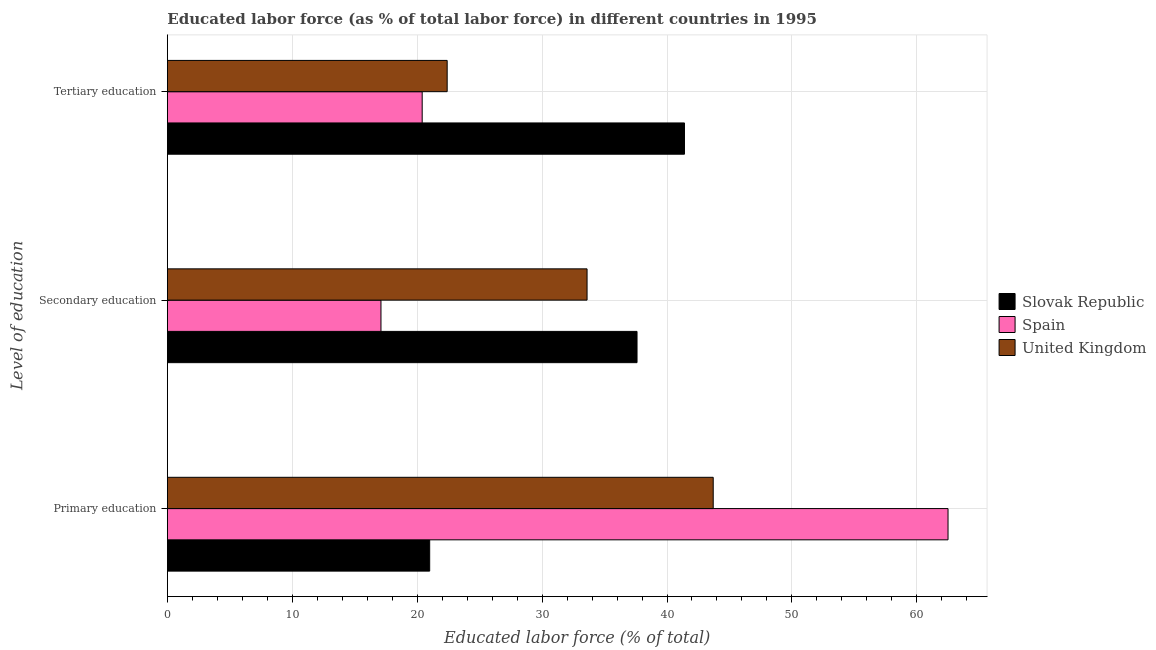How many different coloured bars are there?
Make the answer very short. 3. Are the number of bars per tick equal to the number of legend labels?
Give a very brief answer. Yes. How many bars are there on the 2nd tick from the top?
Offer a very short reply. 3. What is the label of the 2nd group of bars from the top?
Your answer should be very brief. Secondary education. What is the percentage of labor force who received secondary education in Spain?
Your answer should be very brief. 17.1. Across all countries, what is the maximum percentage of labor force who received tertiary education?
Provide a short and direct response. 41.4. In which country was the percentage of labor force who received primary education maximum?
Your response must be concise. Spain. In which country was the percentage of labor force who received secondary education minimum?
Your response must be concise. Spain. What is the total percentage of labor force who received primary education in the graph?
Provide a short and direct response. 127.2. What is the difference between the percentage of labor force who received tertiary education in United Kingdom and that in Spain?
Offer a terse response. 2. What is the difference between the percentage of labor force who received tertiary education in Spain and the percentage of labor force who received primary education in United Kingdom?
Ensure brevity in your answer.  -23.3. What is the average percentage of labor force who received secondary education per country?
Your answer should be very brief. 29.43. What is the difference between the percentage of labor force who received primary education and percentage of labor force who received secondary education in Slovak Republic?
Ensure brevity in your answer.  -16.6. What is the ratio of the percentage of labor force who received secondary education in Spain to that in United Kingdom?
Your answer should be compact. 0.51. Is the difference between the percentage of labor force who received primary education in United Kingdom and Spain greater than the difference between the percentage of labor force who received secondary education in United Kingdom and Spain?
Provide a short and direct response. No. What is the difference between the highest and the lowest percentage of labor force who received secondary education?
Give a very brief answer. 20.5. In how many countries, is the percentage of labor force who received primary education greater than the average percentage of labor force who received primary education taken over all countries?
Make the answer very short. 2. What does the 1st bar from the top in Secondary education represents?
Your response must be concise. United Kingdom. What does the 1st bar from the bottom in Primary education represents?
Offer a terse response. Slovak Republic. How many bars are there?
Provide a succinct answer. 9. Are all the bars in the graph horizontal?
Keep it short and to the point. Yes. How many countries are there in the graph?
Your answer should be very brief. 3. Are the values on the major ticks of X-axis written in scientific E-notation?
Keep it short and to the point. No. Where does the legend appear in the graph?
Your answer should be compact. Center right. What is the title of the graph?
Offer a terse response. Educated labor force (as % of total labor force) in different countries in 1995. What is the label or title of the X-axis?
Offer a very short reply. Educated labor force (% of total). What is the label or title of the Y-axis?
Your answer should be very brief. Level of education. What is the Educated labor force (% of total) of Slovak Republic in Primary education?
Your response must be concise. 21. What is the Educated labor force (% of total) in Spain in Primary education?
Give a very brief answer. 62.5. What is the Educated labor force (% of total) in United Kingdom in Primary education?
Keep it short and to the point. 43.7. What is the Educated labor force (% of total) in Slovak Republic in Secondary education?
Provide a succinct answer. 37.6. What is the Educated labor force (% of total) in Spain in Secondary education?
Provide a succinct answer. 17.1. What is the Educated labor force (% of total) in United Kingdom in Secondary education?
Make the answer very short. 33.6. What is the Educated labor force (% of total) of Slovak Republic in Tertiary education?
Your answer should be compact. 41.4. What is the Educated labor force (% of total) in Spain in Tertiary education?
Give a very brief answer. 20.4. What is the Educated labor force (% of total) of United Kingdom in Tertiary education?
Provide a succinct answer. 22.4. Across all Level of education, what is the maximum Educated labor force (% of total) in Slovak Republic?
Give a very brief answer. 41.4. Across all Level of education, what is the maximum Educated labor force (% of total) in Spain?
Make the answer very short. 62.5. Across all Level of education, what is the maximum Educated labor force (% of total) of United Kingdom?
Your response must be concise. 43.7. Across all Level of education, what is the minimum Educated labor force (% of total) of Spain?
Provide a succinct answer. 17.1. Across all Level of education, what is the minimum Educated labor force (% of total) in United Kingdom?
Offer a terse response. 22.4. What is the total Educated labor force (% of total) in Slovak Republic in the graph?
Offer a very short reply. 100. What is the total Educated labor force (% of total) in Spain in the graph?
Your answer should be very brief. 100. What is the total Educated labor force (% of total) in United Kingdom in the graph?
Provide a short and direct response. 99.7. What is the difference between the Educated labor force (% of total) in Slovak Republic in Primary education and that in Secondary education?
Provide a short and direct response. -16.6. What is the difference between the Educated labor force (% of total) of Spain in Primary education and that in Secondary education?
Your answer should be compact. 45.4. What is the difference between the Educated labor force (% of total) in Slovak Republic in Primary education and that in Tertiary education?
Ensure brevity in your answer.  -20.4. What is the difference between the Educated labor force (% of total) in Spain in Primary education and that in Tertiary education?
Your answer should be compact. 42.1. What is the difference between the Educated labor force (% of total) in United Kingdom in Primary education and that in Tertiary education?
Keep it short and to the point. 21.3. What is the difference between the Educated labor force (% of total) of Slovak Republic in Secondary education and that in Tertiary education?
Offer a terse response. -3.8. What is the difference between the Educated labor force (% of total) in Slovak Republic in Primary education and the Educated labor force (% of total) in Spain in Secondary education?
Offer a very short reply. 3.9. What is the difference between the Educated labor force (% of total) in Slovak Republic in Primary education and the Educated labor force (% of total) in United Kingdom in Secondary education?
Offer a terse response. -12.6. What is the difference between the Educated labor force (% of total) of Spain in Primary education and the Educated labor force (% of total) of United Kingdom in Secondary education?
Offer a terse response. 28.9. What is the difference between the Educated labor force (% of total) in Slovak Republic in Primary education and the Educated labor force (% of total) in Spain in Tertiary education?
Offer a very short reply. 0.6. What is the difference between the Educated labor force (% of total) of Spain in Primary education and the Educated labor force (% of total) of United Kingdom in Tertiary education?
Provide a succinct answer. 40.1. What is the difference between the Educated labor force (% of total) of Slovak Republic in Secondary education and the Educated labor force (% of total) of United Kingdom in Tertiary education?
Provide a short and direct response. 15.2. What is the difference between the Educated labor force (% of total) in Spain in Secondary education and the Educated labor force (% of total) in United Kingdom in Tertiary education?
Your response must be concise. -5.3. What is the average Educated labor force (% of total) of Slovak Republic per Level of education?
Your response must be concise. 33.33. What is the average Educated labor force (% of total) in Spain per Level of education?
Your response must be concise. 33.33. What is the average Educated labor force (% of total) of United Kingdom per Level of education?
Your answer should be very brief. 33.23. What is the difference between the Educated labor force (% of total) in Slovak Republic and Educated labor force (% of total) in Spain in Primary education?
Your answer should be compact. -41.5. What is the difference between the Educated labor force (% of total) of Slovak Republic and Educated labor force (% of total) of United Kingdom in Primary education?
Give a very brief answer. -22.7. What is the difference between the Educated labor force (% of total) in Spain and Educated labor force (% of total) in United Kingdom in Primary education?
Provide a succinct answer. 18.8. What is the difference between the Educated labor force (% of total) of Slovak Republic and Educated labor force (% of total) of Spain in Secondary education?
Make the answer very short. 20.5. What is the difference between the Educated labor force (% of total) of Spain and Educated labor force (% of total) of United Kingdom in Secondary education?
Provide a short and direct response. -16.5. What is the difference between the Educated labor force (% of total) in Slovak Republic and Educated labor force (% of total) in Spain in Tertiary education?
Make the answer very short. 21. What is the difference between the Educated labor force (% of total) of Slovak Republic and Educated labor force (% of total) of United Kingdom in Tertiary education?
Provide a succinct answer. 19. What is the difference between the Educated labor force (% of total) of Spain and Educated labor force (% of total) of United Kingdom in Tertiary education?
Give a very brief answer. -2. What is the ratio of the Educated labor force (% of total) of Slovak Republic in Primary education to that in Secondary education?
Offer a very short reply. 0.56. What is the ratio of the Educated labor force (% of total) of Spain in Primary education to that in Secondary education?
Ensure brevity in your answer.  3.65. What is the ratio of the Educated labor force (% of total) in United Kingdom in Primary education to that in Secondary education?
Give a very brief answer. 1.3. What is the ratio of the Educated labor force (% of total) of Slovak Republic in Primary education to that in Tertiary education?
Offer a terse response. 0.51. What is the ratio of the Educated labor force (% of total) in Spain in Primary education to that in Tertiary education?
Make the answer very short. 3.06. What is the ratio of the Educated labor force (% of total) of United Kingdom in Primary education to that in Tertiary education?
Make the answer very short. 1.95. What is the ratio of the Educated labor force (% of total) of Slovak Republic in Secondary education to that in Tertiary education?
Make the answer very short. 0.91. What is the ratio of the Educated labor force (% of total) in Spain in Secondary education to that in Tertiary education?
Your answer should be compact. 0.84. What is the difference between the highest and the second highest Educated labor force (% of total) in Slovak Republic?
Provide a short and direct response. 3.8. What is the difference between the highest and the second highest Educated labor force (% of total) of Spain?
Offer a terse response. 42.1. What is the difference between the highest and the second highest Educated labor force (% of total) in United Kingdom?
Your answer should be very brief. 10.1. What is the difference between the highest and the lowest Educated labor force (% of total) in Slovak Republic?
Offer a terse response. 20.4. What is the difference between the highest and the lowest Educated labor force (% of total) of Spain?
Make the answer very short. 45.4. What is the difference between the highest and the lowest Educated labor force (% of total) of United Kingdom?
Ensure brevity in your answer.  21.3. 